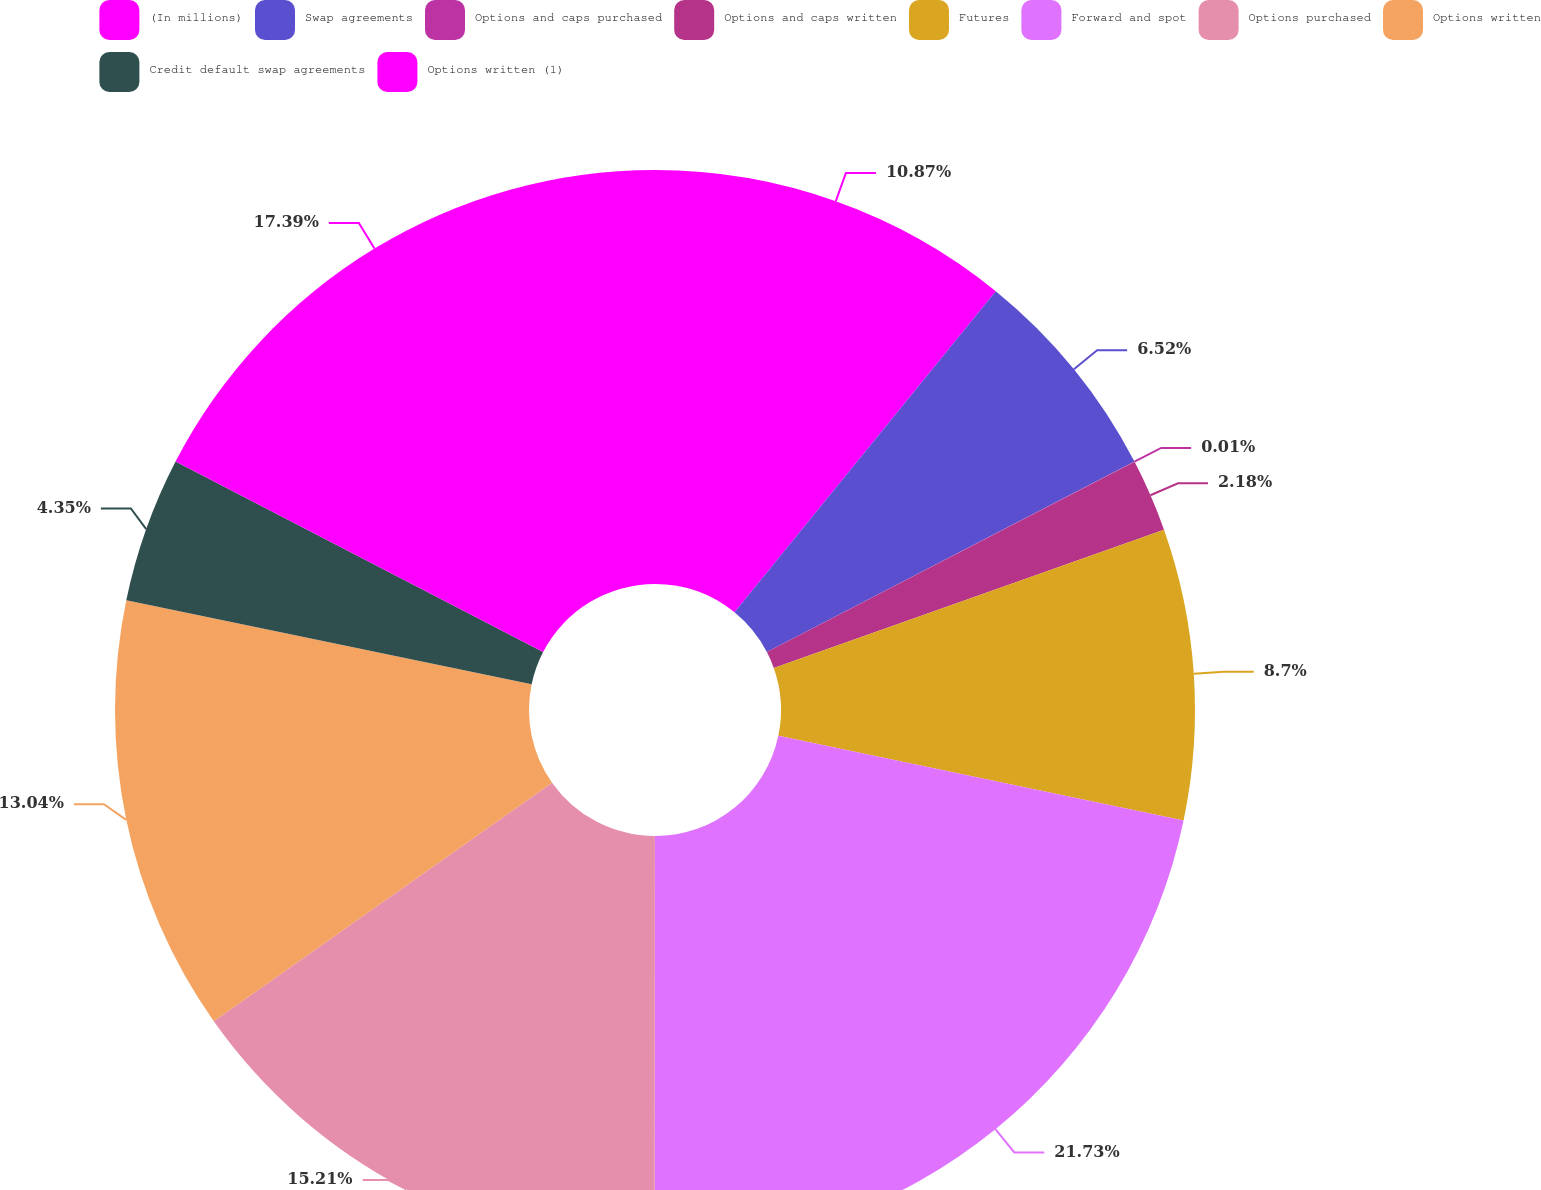Convert chart to OTSL. <chart><loc_0><loc_0><loc_500><loc_500><pie_chart><fcel>(In millions)<fcel>Swap agreements<fcel>Options and caps purchased<fcel>Options and caps written<fcel>Futures<fcel>Forward and spot<fcel>Options purchased<fcel>Options written<fcel>Credit default swap agreements<fcel>Options written (1)<nl><fcel>10.87%<fcel>6.52%<fcel>0.01%<fcel>2.18%<fcel>8.7%<fcel>21.73%<fcel>15.21%<fcel>13.04%<fcel>4.35%<fcel>17.39%<nl></chart> 